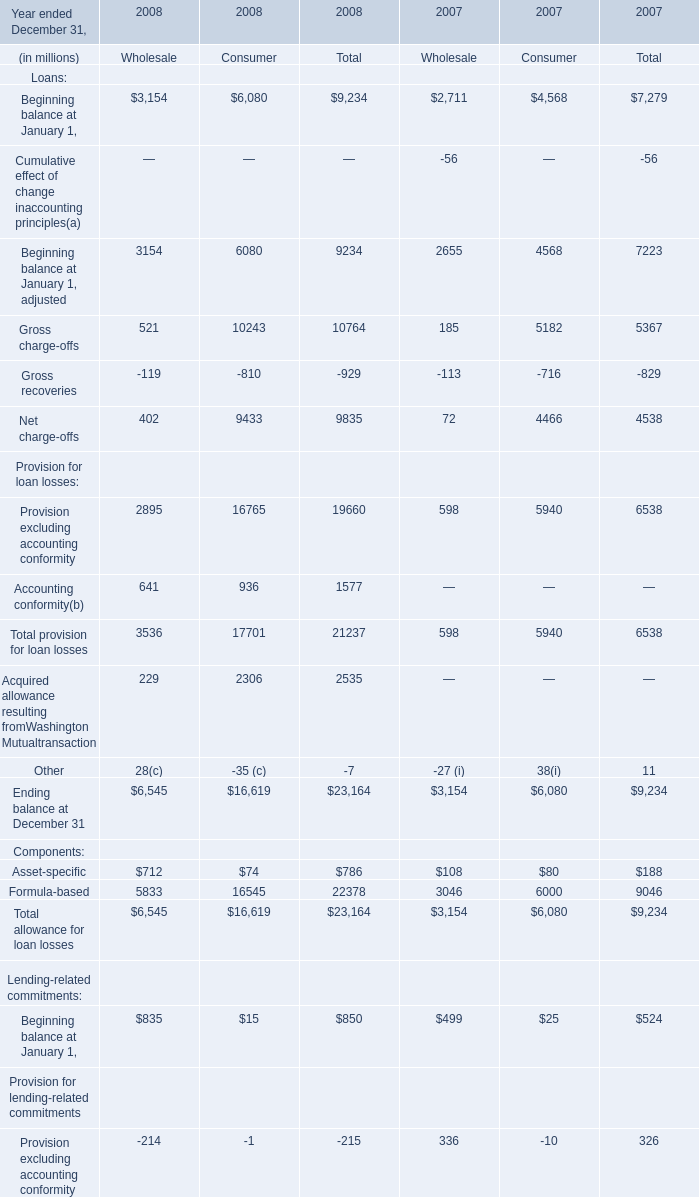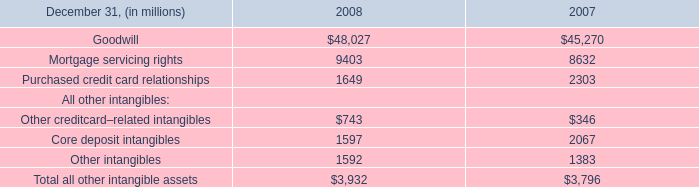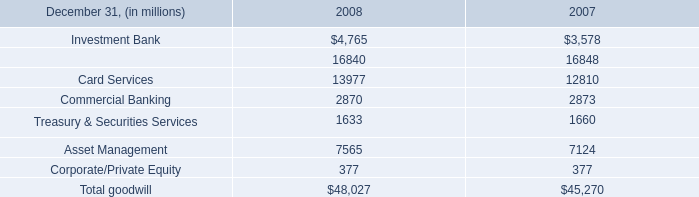What was the average of the Net charge-offs in the years where Gross charge-offs is positive? (in million) 
Computations: ((((((402 + 9433) + 9835) + 72) + 4466) + 4538) / 6)
Answer: 4791.0. 